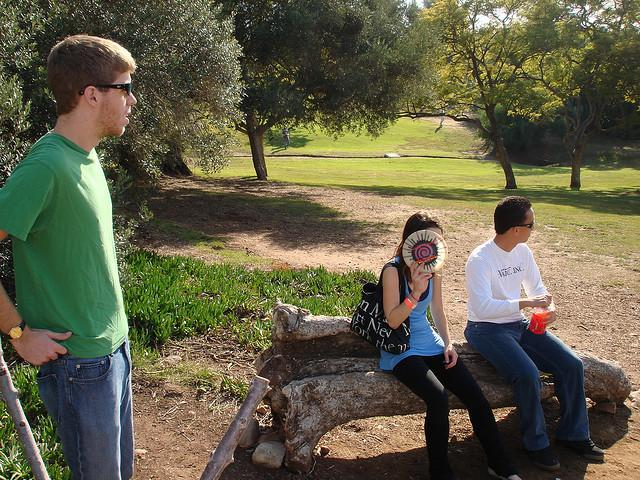Why is she holding up the item?

Choices:
A) listening
B) throwing
C) afraid
D) camera shy camera shy 